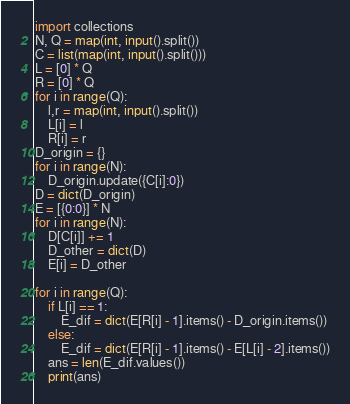Convert code to text. <code><loc_0><loc_0><loc_500><loc_500><_Python_>import collections
N, Q = map(int, input().split())
C = list(map(int, input().split()))
L = [0] * Q
R = [0] * Q
for i in range(Q):
    l,r = map(int, input().split())
    L[i] = l
    R[i] = r
D_origin = {}
for i in range(N):
    D_origin.update({C[i]:0})
D = dict(D_origin)
E = [{0:0}] * N
for i in range(N):
    D[C[i]] += 1
    D_other = dict(D)
    E[i] = D_other

for i in range(Q):
    if L[i] == 1:
        E_dif = dict(E[R[i] - 1].items() - D_origin.items())
    else:
        E_dif = dict(E[R[i] - 1].items() - E[L[i] - 2].items())
    ans = len(E_dif.values())
    print(ans)</code> 